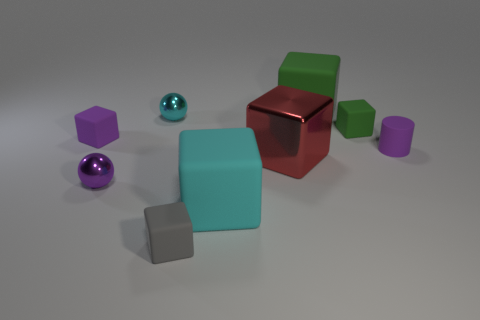Subtract all big green cubes. How many cubes are left? 5 Subtract 1 cubes. How many cubes are left? 5 Subtract all gray cubes. How many cubes are left? 5 Subtract all brown blocks. Subtract all purple cylinders. How many blocks are left? 6 Add 1 big red shiny blocks. How many objects exist? 10 Subtract all spheres. How many objects are left? 7 Add 4 small gray cubes. How many small gray cubes exist? 5 Subtract 1 cyan cubes. How many objects are left? 8 Subtract all cyan matte objects. Subtract all small green things. How many objects are left? 7 Add 9 tiny cyan metal spheres. How many tiny cyan metal spheres are left? 10 